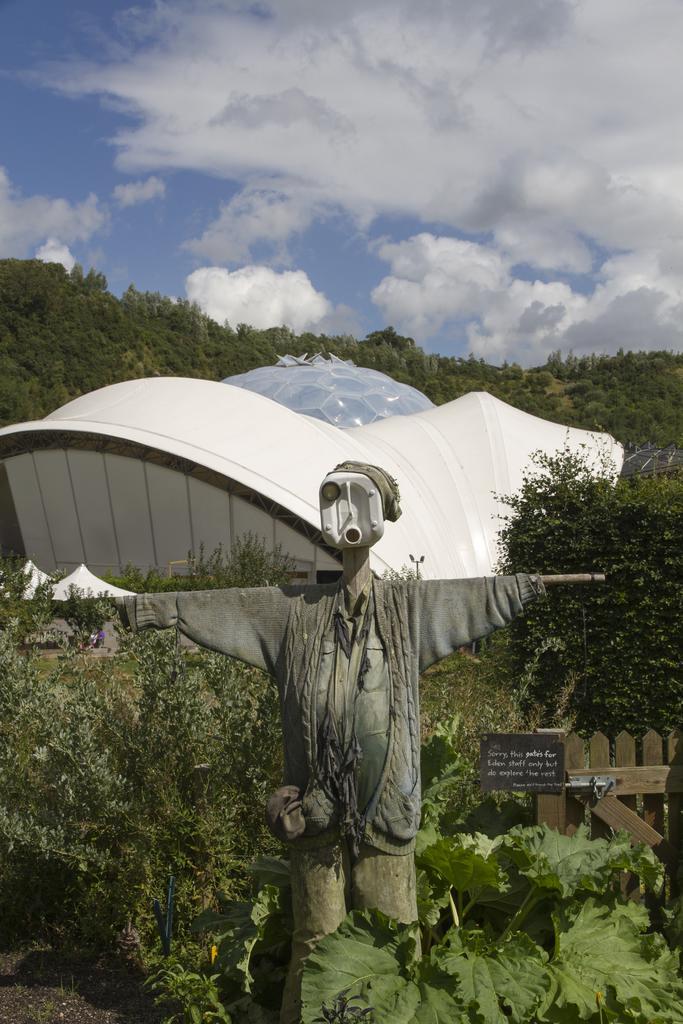Describe this image in one or two sentences. In the center of the image there is a depiction of persons. In the background of the image there are trees. There is a house. In the background of the image there is sky and clouds. 